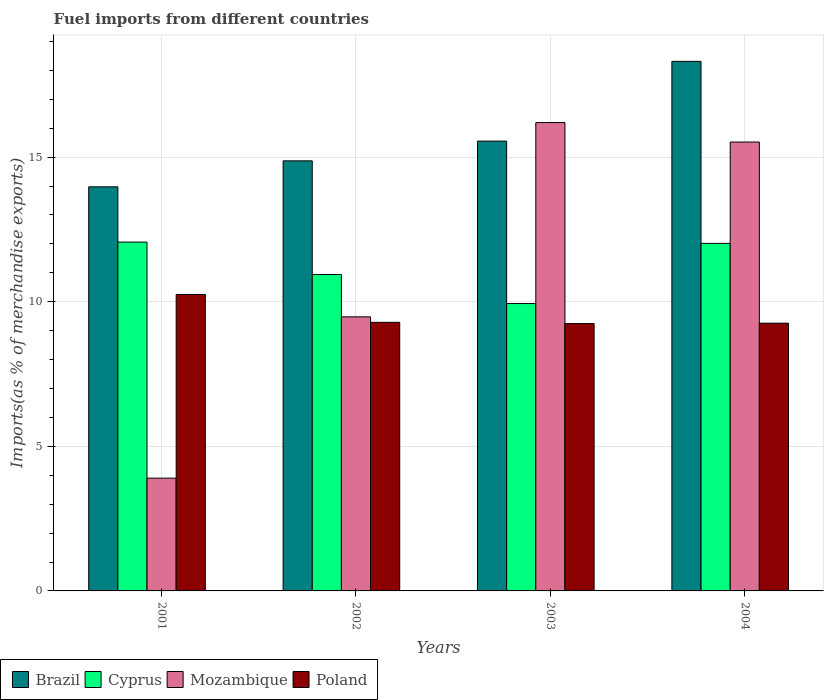How many different coloured bars are there?
Your answer should be compact. 4. Are the number of bars per tick equal to the number of legend labels?
Make the answer very short. Yes. Are the number of bars on each tick of the X-axis equal?
Provide a succinct answer. Yes. How many bars are there on the 1st tick from the right?
Provide a short and direct response. 4. In how many cases, is the number of bars for a given year not equal to the number of legend labels?
Your answer should be compact. 0. What is the percentage of imports to different countries in Poland in 2002?
Provide a succinct answer. 9.29. Across all years, what is the maximum percentage of imports to different countries in Cyprus?
Provide a short and direct response. 12.06. Across all years, what is the minimum percentage of imports to different countries in Brazil?
Offer a terse response. 13.97. In which year was the percentage of imports to different countries in Mozambique minimum?
Provide a succinct answer. 2001. What is the total percentage of imports to different countries in Brazil in the graph?
Offer a very short reply. 62.71. What is the difference between the percentage of imports to different countries in Brazil in 2002 and that in 2003?
Provide a short and direct response. -0.68. What is the difference between the percentage of imports to different countries in Brazil in 2003 and the percentage of imports to different countries in Mozambique in 2004?
Make the answer very short. 0.03. What is the average percentage of imports to different countries in Mozambique per year?
Ensure brevity in your answer.  11.27. In the year 2002, what is the difference between the percentage of imports to different countries in Cyprus and percentage of imports to different countries in Poland?
Your response must be concise. 1.65. In how many years, is the percentage of imports to different countries in Cyprus greater than 9 %?
Keep it short and to the point. 4. What is the ratio of the percentage of imports to different countries in Poland in 2002 to that in 2004?
Provide a short and direct response. 1. Is the percentage of imports to different countries in Poland in 2001 less than that in 2002?
Make the answer very short. No. What is the difference between the highest and the second highest percentage of imports to different countries in Cyprus?
Offer a very short reply. 0.04. What is the difference between the highest and the lowest percentage of imports to different countries in Brazil?
Offer a terse response. 4.34. In how many years, is the percentage of imports to different countries in Cyprus greater than the average percentage of imports to different countries in Cyprus taken over all years?
Provide a short and direct response. 2. Is the sum of the percentage of imports to different countries in Brazil in 2001 and 2003 greater than the maximum percentage of imports to different countries in Poland across all years?
Your response must be concise. Yes. What does the 3rd bar from the left in 2002 represents?
Your answer should be very brief. Mozambique. What does the 4th bar from the right in 2004 represents?
Your answer should be compact. Brazil. Is it the case that in every year, the sum of the percentage of imports to different countries in Brazil and percentage of imports to different countries in Poland is greater than the percentage of imports to different countries in Mozambique?
Your response must be concise. Yes. How many bars are there?
Provide a short and direct response. 16. Are all the bars in the graph horizontal?
Your answer should be very brief. No. What is the difference between two consecutive major ticks on the Y-axis?
Your answer should be very brief. 5. Are the values on the major ticks of Y-axis written in scientific E-notation?
Ensure brevity in your answer.  No. Does the graph contain any zero values?
Offer a very short reply. No. What is the title of the graph?
Ensure brevity in your answer.  Fuel imports from different countries. Does "Bosnia and Herzegovina" appear as one of the legend labels in the graph?
Your answer should be very brief. No. What is the label or title of the Y-axis?
Give a very brief answer. Imports(as % of merchandise exports). What is the Imports(as % of merchandise exports) in Brazil in 2001?
Offer a terse response. 13.97. What is the Imports(as % of merchandise exports) of Cyprus in 2001?
Offer a very short reply. 12.06. What is the Imports(as % of merchandise exports) of Mozambique in 2001?
Offer a terse response. 3.9. What is the Imports(as % of merchandise exports) in Poland in 2001?
Ensure brevity in your answer.  10.25. What is the Imports(as % of merchandise exports) of Brazil in 2002?
Ensure brevity in your answer.  14.87. What is the Imports(as % of merchandise exports) in Cyprus in 2002?
Your response must be concise. 10.94. What is the Imports(as % of merchandise exports) of Mozambique in 2002?
Ensure brevity in your answer.  9.48. What is the Imports(as % of merchandise exports) in Poland in 2002?
Keep it short and to the point. 9.29. What is the Imports(as % of merchandise exports) in Brazil in 2003?
Provide a short and direct response. 15.55. What is the Imports(as % of merchandise exports) of Cyprus in 2003?
Your response must be concise. 9.94. What is the Imports(as % of merchandise exports) of Mozambique in 2003?
Your answer should be very brief. 16.2. What is the Imports(as % of merchandise exports) in Poland in 2003?
Make the answer very short. 9.24. What is the Imports(as % of merchandise exports) of Brazil in 2004?
Provide a short and direct response. 18.31. What is the Imports(as % of merchandise exports) of Cyprus in 2004?
Make the answer very short. 12.02. What is the Imports(as % of merchandise exports) in Mozambique in 2004?
Make the answer very short. 15.52. What is the Imports(as % of merchandise exports) of Poland in 2004?
Ensure brevity in your answer.  9.26. Across all years, what is the maximum Imports(as % of merchandise exports) in Brazil?
Make the answer very short. 18.31. Across all years, what is the maximum Imports(as % of merchandise exports) in Cyprus?
Your response must be concise. 12.06. Across all years, what is the maximum Imports(as % of merchandise exports) of Mozambique?
Ensure brevity in your answer.  16.2. Across all years, what is the maximum Imports(as % of merchandise exports) in Poland?
Provide a short and direct response. 10.25. Across all years, what is the minimum Imports(as % of merchandise exports) of Brazil?
Offer a terse response. 13.97. Across all years, what is the minimum Imports(as % of merchandise exports) in Cyprus?
Your response must be concise. 9.94. Across all years, what is the minimum Imports(as % of merchandise exports) in Mozambique?
Offer a very short reply. 3.9. Across all years, what is the minimum Imports(as % of merchandise exports) of Poland?
Provide a short and direct response. 9.24. What is the total Imports(as % of merchandise exports) of Brazil in the graph?
Your answer should be very brief. 62.71. What is the total Imports(as % of merchandise exports) of Cyprus in the graph?
Give a very brief answer. 44.96. What is the total Imports(as % of merchandise exports) of Mozambique in the graph?
Your response must be concise. 45.1. What is the total Imports(as % of merchandise exports) of Poland in the graph?
Offer a very short reply. 38.04. What is the difference between the Imports(as % of merchandise exports) of Brazil in 2001 and that in 2002?
Provide a short and direct response. -0.9. What is the difference between the Imports(as % of merchandise exports) of Cyprus in 2001 and that in 2002?
Provide a short and direct response. 1.12. What is the difference between the Imports(as % of merchandise exports) in Mozambique in 2001 and that in 2002?
Your response must be concise. -5.58. What is the difference between the Imports(as % of merchandise exports) in Poland in 2001 and that in 2002?
Offer a very short reply. 0.96. What is the difference between the Imports(as % of merchandise exports) of Brazil in 2001 and that in 2003?
Keep it short and to the point. -1.58. What is the difference between the Imports(as % of merchandise exports) of Cyprus in 2001 and that in 2003?
Offer a very short reply. 2.13. What is the difference between the Imports(as % of merchandise exports) of Mozambique in 2001 and that in 2003?
Your answer should be compact. -12.3. What is the difference between the Imports(as % of merchandise exports) in Poland in 2001 and that in 2003?
Make the answer very short. 1.01. What is the difference between the Imports(as % of merchandise exports) of Brazil in 2001 and that in 2004?
Provide a short and direct response. -4.34. What is the difference between the Imports(as % of merchandise exports) in Cyprus in 2001 and that in 2004?
Your answer should be compact. 0.04. What is the difference between the Imports(as % of merchandise exports) of Mozambique in 2001 and that in 2004?
Make the answer very short. -11.62. What is the difference between the Imports(as % of merchandise exports) in Brazil in 2002 and that in 2003?
Your answer should be very brief. -0.68. What is the difference between the Imports(as % of merchandise exports) of Mozambique in 2002 and that in 2003?
Give a very brief answer. -6.72. What is the difference between the Imports(as % of merchandise exports) of Poland in 2002 and that in 2003?
Offer a terse response. 0.04. What is the difference between the Imports(as % of merchandise exports) of Brazil in 2002 and that in 2004?
Provide a succinct answer. -3.44. What is the difference between the Imports(as % of merchandise exports) in Cyprus in 2002 and that in 2004?
Provide a short and direct response. -1.08. What is the difference between the Imports(as % of merchandise exports) in Mozambique in 2002 and that in 2004?
Give a very brief answer. -6.04. What is the difference between the Imports(as % of merchandise exports) in Poland in 2002 and that in 2004?
Offer a very short reply. 0.03. What is the difference between the Imports(as % of merchandise exports) in Brazil in 2003 and that in 2004?
Make the answer very short. -2.76. What is the difference between the Imports(as % of merchandise exports) of Cyprus in 2003 and that in 2004?
Ensure brevity in your answer.  -2.08. What is the difference between the Imports(as % of merchandise exports) of Mozambique in 2003 and that in 2004?
Ensure brevity in your answer.  0.67. What is the difference between the Imports(as % of merchandise exports) in Poland in 2003 and that in 2004?
Make the answer very short. -0.01. What is the difference between the Imports(as % of merchandise exports) in Brazil in 2001 and the Imports(as % of merchandise exports) in Cyprus in 2002?
Your answer should be compact. 3.03. What is the difference between the Imports(as % of merchandise exports) of Brazil in 2001 and the Imports(as % of merchandise exports) of Mozambique in 2002?
Provide a short and direct response. 4.5. What is the difference between the Imports(as % of merchandise exports) in Brazil in 2001 and the Imports(as % of merchandise exports) in Poland in 2002?
Provide a succinct answer. 4.69. What is the difference between the Imports(as % of merchandise exports) of Cyprus in 2001 and the Imports(as % of merchandise exports) of Mozambique in 2002?
Give a very brief answer. 2.59. What is the difference between the Imports(as % of merchandise exports) of Cyprus in 2001 and the Imports(as % of merchandise exports) of Poland in 2002?
Provide a short and direct response. 2.77. What is the difference between the Imports(as % of merchandise exports) of Mozambique in 2001 and the Imports(as % of merchandise exports) of Poland in 2002?
Provide a short and direct response. -5.39. What is the difference between the Imports(as % of merchandise exports) in Brazil in 2001 and the Imports(as % of merchandise exports) in Cyprus in 2003?
Make the answer very short. 4.04. What is the difference between the Imports(as % of merchandise exports) in Brazil in 2001 and the Imports(as % of merchandise exports) in Mozambique in 2003?
Ensure brevity in your answer.  -2.22. What is the difference between the Imports(as % of merchandise exports) in Brazil in 2001 and the Imports(as % of merchandise exports) in Poland in 2003?
Give a very brief answer. 4.73. What is the difference between the Imports(as % of merchandise exports) of Cyprus in 2001 and the Imports(as % of merchandise exports) of Mozambique in 2003?
Your response must be concise. -4.13. What is the difference between the Imports(as % of merchandise exports) in Cyprus in 2001 and the Imports(as % of merchandise exports) in Poland in 2003?
Keep it short and to the point. 2.82. What is the difference between the Imports(as % of merchandise exports) in Mozambique in 2001 and the Imports(as % of merchandise exports) in Poland in 2003?
Give a very brief answer. -5.34. What is the difference between the Imports(as % of merchandise exports) of Brazil in 2001 and the Imports(as % of merchandise exports) of Cyprus in 2004?
Provide a succinct answer. 1.96. What is the difference between the Imports(as % of merchandise exports) in Brazil in 2001 and the Imports(as % of merchandise exports) in Mozambique in 2004?
Provide a succinct answer. -1.55. What is the difference between the Imports(as % of merchandise exports) in Brazil in 2001 and the Imports(as % of merchandise exports) in Poland in 2004?
Offer a very short reply. 4.72. What is the difference between the Imports(as % of merchandise exports) of Cyprus in 2001 and the Imports(as % of merchandise exports) of Mozambique in 2004?
Your response must be concise. -3.46. What is the difference between the Imports(as % of merchandise exports) of Cyprus in 2001 and the Imports(as % of merchandise exports) of Poland in 2004?
Provide a succinct answer. 2.8. What is the difference between the Imports(as % of merchandise exports) in Mozambique in 2001 and the Imports(as % of merchandise exports) in Poland in 2004?
Your answer should be very brief. -5.36. What is the difference between the Imports(as % of merchandise exports) of Brazil in 2002 and the Imports(as % of merchandise exports) of Cyprus in 2003?
Offer a very short reply. 4.93. What is the difference between the Imports(as % of merchandise exports) in Brazil in 2002 and the Imports(as % of merchandise exports) in Mozambique in 2003?
Your answer should be very brief. -1.32. What is the difference between the Imports(as % of merchandise exports) in Brazil in 2002 and the Imports(as % of merchandise exports) in Poland in 2003?
Make the answer very short. 5.63. What is the difference between the Imports(as % of merchandise exports) of Cyprus in 2002 and the Imports(as % of merchandise exports) of Mozambique in 2003?
Provide a short and direct response. -5.25. What is the difference between the Imports(as % of merchandise exports) in Cyprus in 2002 and the Imports(as % of merchandise exports) in Poland in 2003?
Offer a terse response. 1.7. What is the difference between the Imports(as % of merchandise exports) in Mozambique in 2002 and the Imports(as % of merchandise exports) in Poland in 2003?
Offer a very short reply. 0.23. What is the difference between the Imports(as % of merchandise exports) of Brazil in 2002 and the Imports(as % of merchandise exports) of Cyprus in 2004?
Give a very brief answer. 2.85. What is the difference between the Imports(as % of merchandise exports) in Brazil in 2002 and the Imports(as % of merchandise exports) in Mozambique in 2004?
Your answer should be compact. -0.65. What is the difference between the Imports(as % of merchandise exports) of Brazil in 2002 and the Imports(as % of merchandise exports) of Poland in 2004?
Make the answer very short. 5.61. What is the difference between the Imports(as % of merchandise exports) of Cyprus in 2002 and the Imports(as % of merchandise exports) of Mozambique in 2004?
Provide a succinct answer. -4.58. What is the difference between the Imports(as % of merchandise exports) in Cyprus in 2002 and the Imports(as % of merchandise exports) in Poland in 2004?
Give a very brief answer. 1.68. What is the difference between the Imports(as % of merchandise exports) of Mozambique in 2002 and the Imports(as % of merchandise exports) of Poland in 2004?
Keep it short and to the point. 0.22. What is the difference between the Imports(as % of merchandise exports) of Brazil in 2003 and the Imports(as % of merchandise exports) of Cyprus in 2004?
Your answer should be compact. 3.54. What is the difference between the Imports(as % of merchandise exports) in Brazil in 2003 and the Imports(as % of merchandise exports) in Mozambique in 2004?
Your answer should be very brief. 0.03. What is the difference between the Imports(as % of merchandise exports) in Brazil in 2003 and the Imports(as % of merchandise exports) in Poland in 2004?
Provide a succinct answer. 6.3. What is the difference between the Imports(as % of merchandise exports) in Cyprus in 2003 and the Imports(as % of merchandise exports) in Mozambique in 2004?
Keep it short and to the point. -5.58. What is the difference between the Imports(as % of merchandise exports) in Cyprus in 2003 and the Imports(as % of merchandise exports) in Poland in 2004?
Make the answer very short. 0.68. What is the difference between the Imports(as % of merchandise exports) of Mozambique in 2003 and the Imports(as % of merchandise exports) of Poland in 2004?
Your answer should be compact. 6.94. What is the average Imports(as % of merchandise exports) in Brazil per year?
Your answer should be very brief. 15.68. What is the average Imports(as % of merchandise exports) of Cyprus per year?
Your answer should be very brief. 11.24. What is the average Imports(as % of merchandise exports) in Mozambique per year?
Provide a succinct answer. 11.27. What is the average Imports(as % of merchandise exports) of Poland per year?
Ensure brevity in your answer.  9.51. In the year 2001, what is the difference between the Imports(as % of merchandise exports) in Brazil and Imports(as % of merchandise exports) in Cyprus?
Make the answer very short. 1.91. In the year 2001, what is the difference between the Imports(as % of merchandise exports) in Brazil and Imports(as % of merchandise exports) in Mozambique?
Your answer should be compact. 10.07. In the year 2001, what is the difference between the Imports(as % of merchandise exports) in Brazil and Imports(as % of merchandise exports) in Poland?
Your response must be concise. 3.72. In the year 2001, what is the difference between the Imports(as % of merchandise exports) of Cyprus and Imports(as % of merchandise exports) of Mozambique?
Keep it short and to the point. 8.16. In the year 2001, what is the difference between the Imports(as % of merchandise exports) in Cyprus and Imports(as % of merchandise exports) in Poland?
Give a very brief answer. 1.81. In the year 2001, what is the difference between the Imports(as % of merchandise exports) in Mozambique and Imports(as % of merchandise exports) in Poland?
Ensure brevity in your answer.  -6.35. In the year 2002, what is the difference between the Imports(as % of merchandise exports) of Brazil and Imports(as % of merchandise exports) of Cyprus?
Ensure brevity in your answer.  3.93. In the year 2002, what is the difference between the Imports(as % of merchandise exports) of Brazil and Imports(as % of merchandise exports) of Mozambique?
Provide a succinct answer. 5.39. In the year 2002, what is the difference between the Imports(as % of merchandise exports) of Brazil and Imports(as % of merchandise exports) of Poland?
Offer a very short reply. 5.58. In the year 2002, what is the difference between the Imports(as % of merchandise exports) in Cyprus and Imports(as % of merchandise exports) in Mozambique?
Make the answer very short. 1.46. In the year 2002, what is the difference between the Imports(as % of merchandise exports) of Cyprus and Imports(as % of merchandise exports) of Poland?
Provide a short and direct response. 1.65. In the year 2002, what is the difference between the Imports(as % of merchandise exports) in Mozambique and Imports(as % of merchandise exports) in Poland?
Provide a succinct answer. 0.19. In the year 2003, what is the difference between the Imports(as % of merchandise exports) of Brazil and Imports(as % of merchandise exports) of Cyprus?
Provide a succinct answer. 5.62. In the year 2003, what is the difference between the Imports(as % of merchandise exports) in Brazil and Imports(as % of merchandise exports) in Mozambique?
Offer a very short reply. -0.64. In the year 2003, what is the difference between the Imports(as % of merchandise exports) of Brazil and Imports(as % of merchandise exports) of Poland?
Your answer should be compact. 6.31. In the year 2003, what is the difference between the Imports(as % of merchandise exports) of Cyprus and Imports(as % of merchandise exports) of Mozambique?
Provide a short and direct response. -6.26. In the year 2003, what is the difference between the Imports(as % of merchandise exports) in Cyprus and Imports(as % of merchandise exports) in Poland?
Offer a very short reply. 0.69. In the year 2003, what is the difference between the Imports(as % of merchandise exports) in Mozambique and Imports(as % of merchandise exports) in Poland?
Your answer should be compact. 6.95. In the year 2004, what is the difference between the Imports(as % of merchandise exports) in Brazil and Imports(as % of merchandise exports) in Cyprus?
Offer a very short reply. 6.29. In the year 2004, what is the difference between the Imports(as % of merchandise exports) of Brazil and Imports(as % of merchandise exports) of Mozambique?
Ensure brevity in your answer.  2.79. In the year 2004, what is the difference between the Imports(as % of merchandise exports) of Brazil and Imports(as % of merchandise exports) of Poland?
Provide a short and direct response. 9.05. In the year 2004, what is the difference between the Imports(as % of merchandise exports) in Cyprus and Imports(as % of merchandise exports) in Mozambique?
Keep it short and to the point. -3.5. In the year 2004, what is the difference between the Imports(as % of merchandise exports) in Cyprus and Imports(as % of merchandise exports) in Poland?
Ensure brevity in your answer.  2.76. In the year 2004, what is the difference between the Imports(as % of merchandise exports) of Mozambique and Imports(as % of merchandise exports) of Poland?
Provide a succinct answer. 6.26. What is the ratio of the Imports(as % of merchandise exports) in Brazil in 2001 to that in 2002?
Provide a short and direct response. 0.94. What is the ratio of the Imports(as % of merchandise exports) in Cyprus in 2001 to that in 2002?
Make the answer very short. 1.1. What is the ratio of the Imports(as % of merchandise exports) of Mozambique in 2001 to that in 2002?
Offer a terse response. 0.41. What is the ratio of the Imports(as % of merchandise exports) in Poland in 2001 to that in 2002?
Make the answer very short. 1.1. What is the ratio of the Imports(as % of merchandise exports) of Brazil in 2001 to that in 2003?
Keep it short and to the point. 0.9. What is the ratio of the Imports(as % of merchandise exports) in Cyprus in 2001 to that in 2003?
Your answer should be very brief. 1.21. What is the ratio of the Imports(as % of merchandise exports) of Mozambique in 2001 to that in 2003?
Provide a short and direct response. 0.24. What is the ratio of the Imports(as % of merchandise exports) in Poland in 2001 to that in 2003?
Your response must be concise. 1.11. What is the ratio of the Imports(as % of merchandise exports) in Brazil in 2001 to that in 2004?
Offer a very short reply. 0.76. What is the ratio of the Imports(as % of merchandise exports) of Cyprus in 2001 to that in 2004?
Provide a short and direct response. 1. What is the ratio of the Imports(as % of merchandise exports) in Mozambique in 2001 to that in 2004?
Provide a short and direct response. 0.25. What is the ratio of the Imports(as % of merchandise exports) in Poland in 2001 to that in 2004?
Give a very brief answer. 1.11. What is the ratio of the Imports(as % of merchandise exports) of Brazil in 2002 to that in 2003?
Keep it short and to the point. 0.96. What is the ratio of the Imports(as % of merchandise exports) of Cyprus in 2002 to that in 2003?
Make the answer very short. 1.1. What is the ratio of the Imports(as % of merchandise exports) of Mozambique in 2002 to that in 2003?
Provide a succinct answer. 0.59. What is the ratio of the Imports(as % of merchandise exports) of Poland in 2002 to that in 2003?
Make the answer very short. 1. What is the ratio of the Imports(as % of merchandise exports) of Brazil in 2002 to that in 2004?
Ensure brevity in your answer.  0.81. What is the ratio of the Imports(as % of merchandise exports) in Cyprus in 2002 to that in 2004?
Provide a short and direct response. 0.91. What is the ratio of the Imports(as % of merchandise exports) in Mozambique in 2002 to that in 2004?
Keep it short and to the point. 0.61. What is the ratio of the Imports(as % of merchandise exports) in Brazil in 2003 to that in 2004?
Make the answer very short. 0.85. What is the ratio of the Imports(as % of merchandise exports) in Cyprus in 2003 to that in 2004?
Offer a very short reply. 0.83. What is the ratio of the Imports(as % of merchandise exports) of Mozambique in 2003 to that in 2004?
Ensure brevity in your answer.  1.04. What is the difference between the highest and the second highest Imports(as % of merchandise exports) in Brazil?
Provide a succinct answer. 2.76. What is the difference between the highest and the second highest Imports(as % of merchandise exports) of Cyprus?
Provide a succinct answer. 0.04. What is the difference between the highest and the second highest Imports(as % of merchandise exports) of Mozambique?
Offer a terse response. 0.67. What is the difference between the highest and the second highest Imports(as % of merchandise exports) in Poland?
Ensure brevity in your answer.  0.96. What is the difference between the highest and the lowest Imports(as % of merchandise exports) of Brazil?
Your answer should be compact. 4.34. What is the difference between the highest and the lowest Imports(as % of merchandise exports) of Cyprus?
Offer a terse response. 2.13. What is the difference between the highest and the lowest Imports(as % of merchandise exports) of Mozambique?
Provide a succinct answer. 12.3. What is the difference between the highest and the lowest Imports(as % of merchandise exports) in Poland?
Your response must be concise. 1.01. 